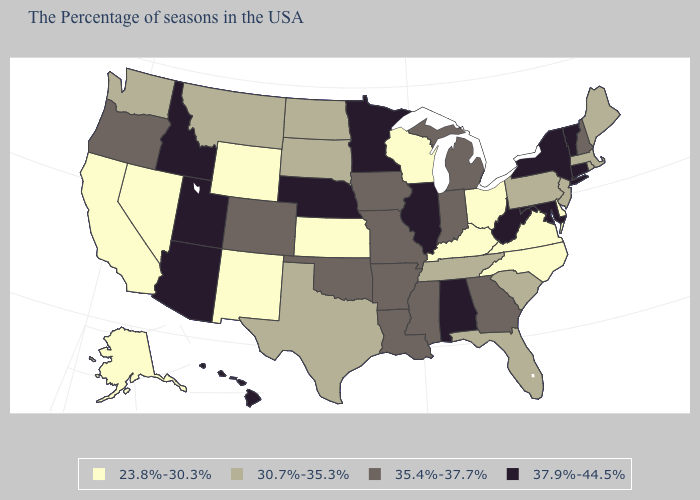What is the lowest value in the West?
Be succinct. 23.8%-30.3%. Does Massachusetts have the same value as Maine?
Concise answer only. Yes. Name the states that have a value in the range 30.7%-35.3%?
Be succinct. Maine, Massachusetts, Rhode Island, New Jersey, Pennsylvania, South Carolina, Florida, Tennessee, Texas, South Dakota, North Dakota, Montana, Washington. Does Hawaii have a higher value than Utah?
Concise answer only. No. What is the lowest value in states that border Indiana?
Give a very brief answer. 23.8%-30.3%. Name the states that have a value in the range 30.7%-35.3%?
Quick response, please. Maine, Massachusetts, Rhode Island, New Jersey, Pennsylvania, South Carolina, Florida, Tennessee, Texas, South Dakota, North Dakota, Montana, Washington. Is the legend a continuous bar?
Be succinct. No. How many symbols are there in the legend?
Be succinct. 4. What is the lowest value in the USA?
Be succinct. 23.8%-30.3%. What is the lowest value in the USA?
Short answer required. 23.8%-30.3%. What is the value of Arizona?
Keep it brief. 37.9%-44.5%. What is the value of Kansas?
Give a very brief answer. 23.8%-30.3%. How many symbols are there in the legend?
Answer briefly. 4. Does Nevada have a lower value than Kentucky?
Keep it brief. No. 